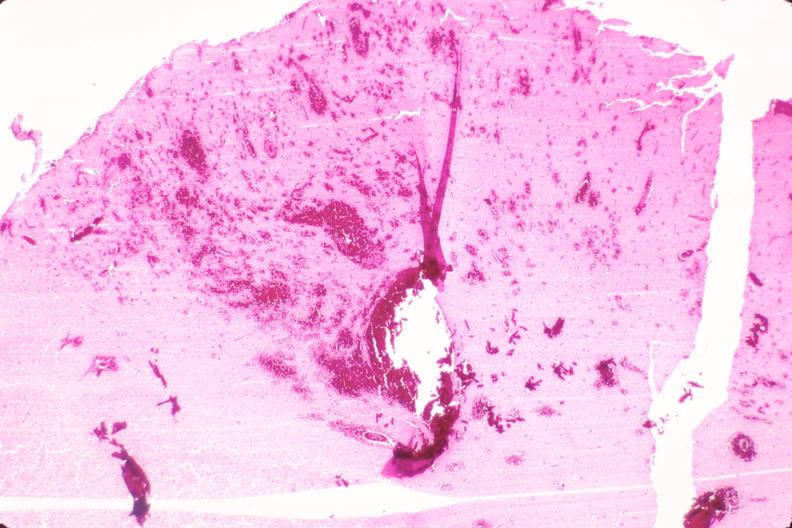what is present?
Answer the question using a single word or phrase. Nervous 